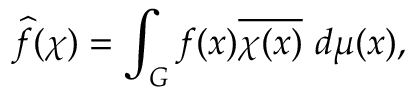Convert formula to latex. <formula><loc_0><loc_0><loc_500><loc_500>{ \widehat { f } } ( \chi ) = \int _ { G } f ( x ) { \overline { \chi ( x ) } } \ d \mu ( x ) ,</formula> 